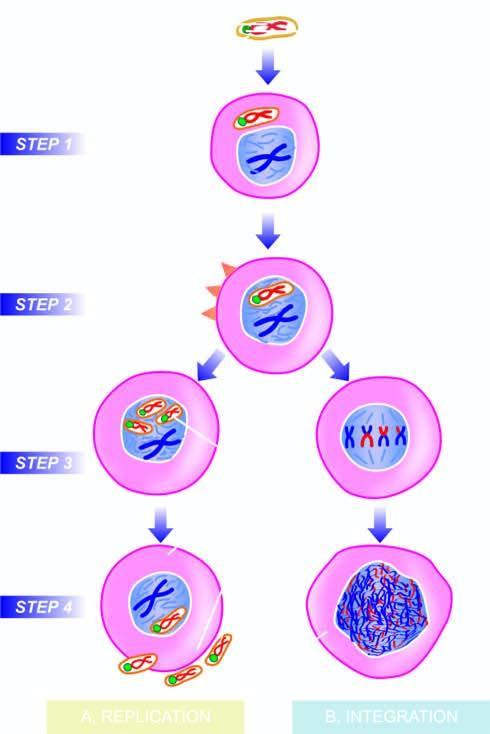re replication of viral dna occurs formed?
Answer the question using a single word or phrase. Yes 